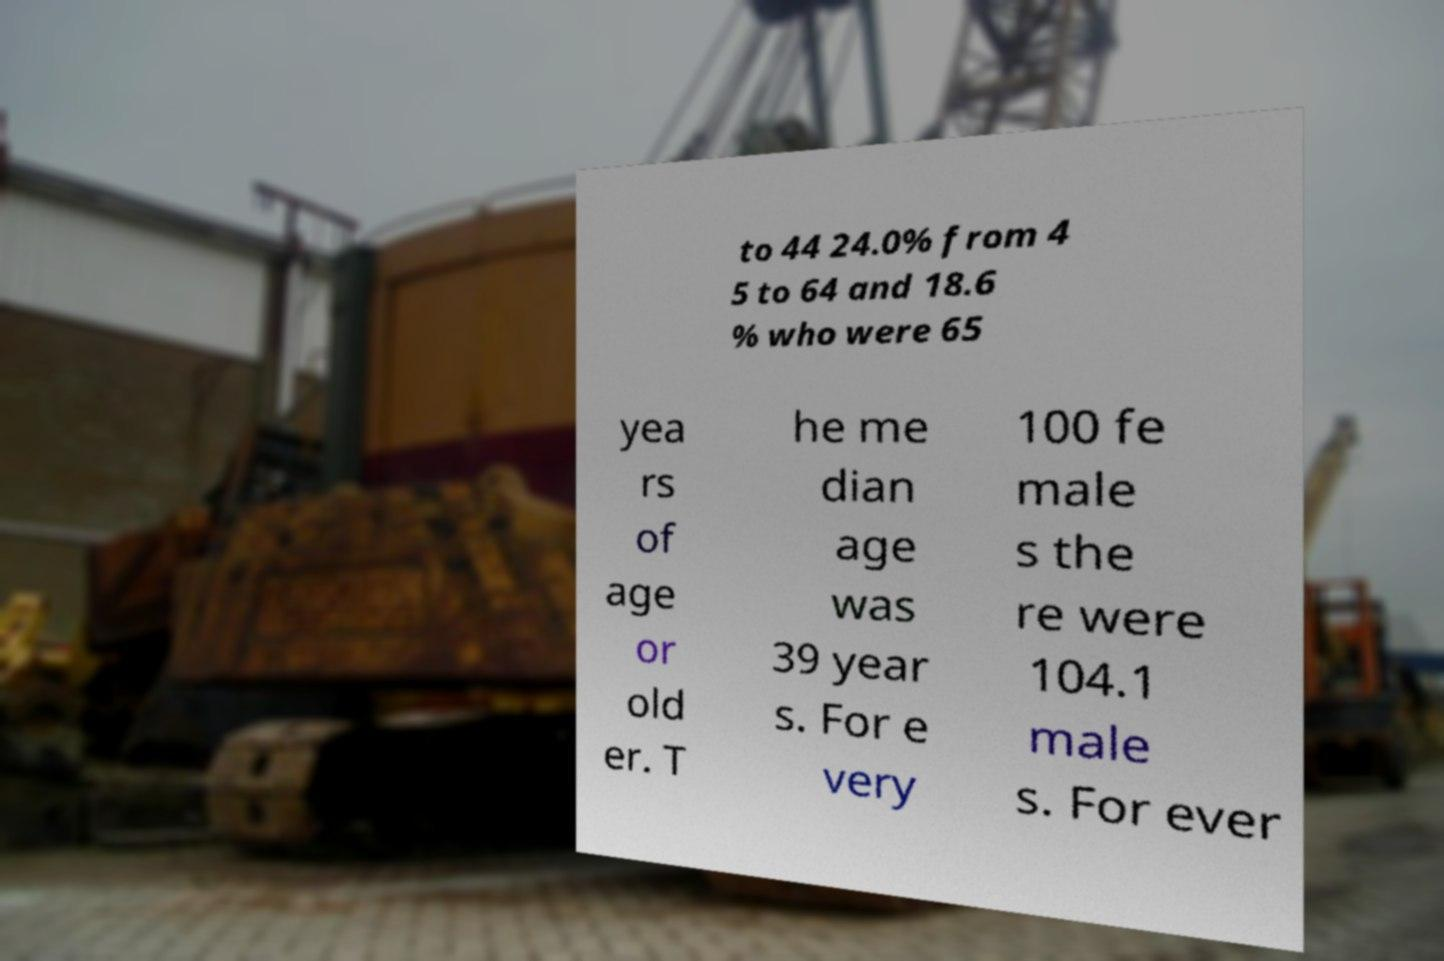Can you accurately transcribe the text from the provided image for me? to 44 24.0% from 4 5 to 64 and 18.6 % who were 65 yea rs of age or old er. T he me dian age was 39 year s. For e very 100 fe male s the re were 104.1 male s. For ever 